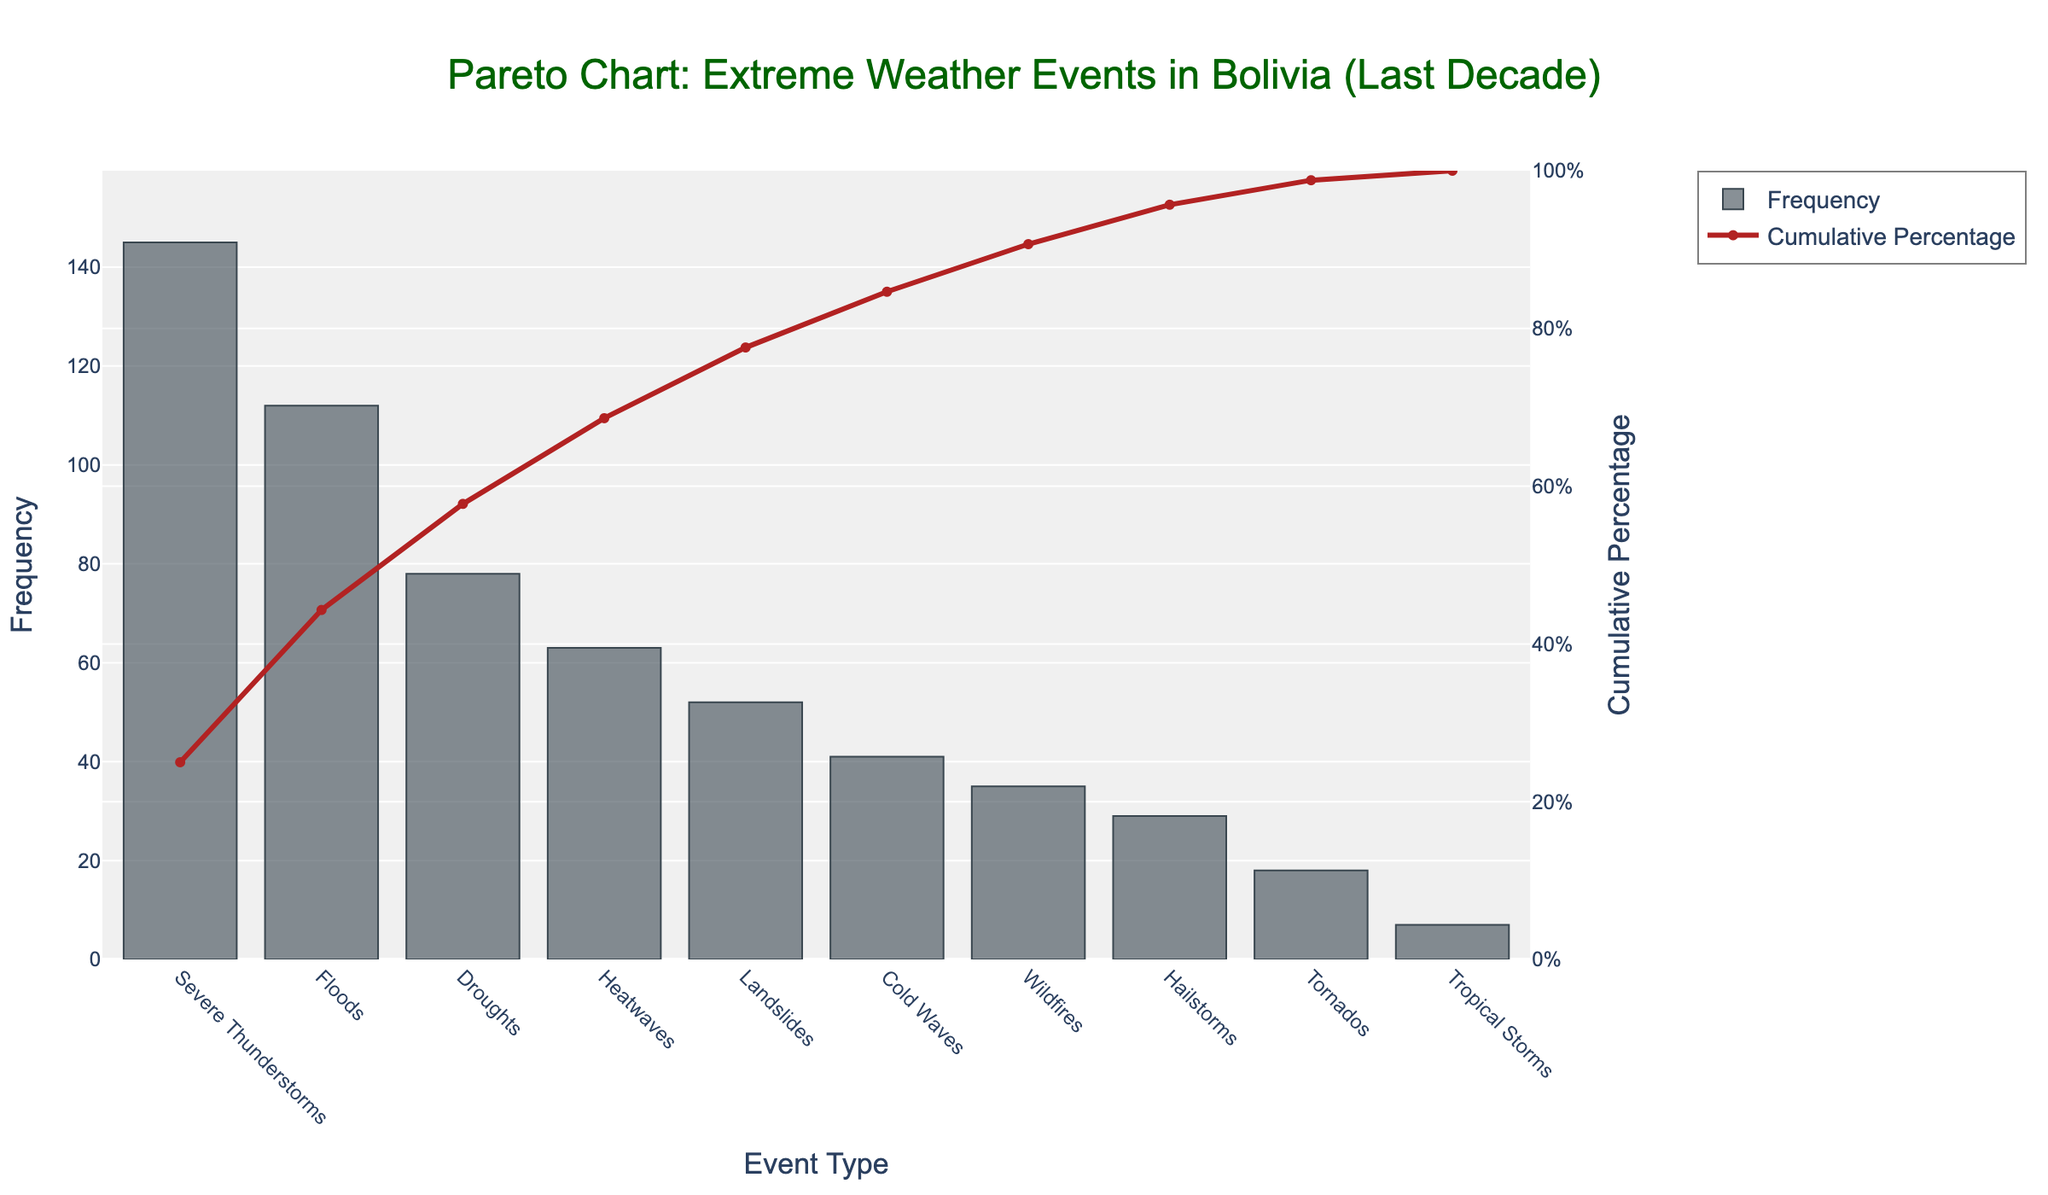How many event types are recorded in the chart? The chart displays 10 types of extreme weather events. You can tell this by counting the unique labels on the x-axis.
Answer: 10 Which extreme weather event has the highest frequency? The event type with the highest bar in the chart represents the one with the highest frequency. In this case, it is "Severe Thunderstorms".
Answer: Severe Thunderstorms What is the cumulative percentage for 'Droughts'? Find the 'Droughts' event type on the x-axis and trace it upwards to the point where its cumulative percentage line intersects the secondary y-axis. The cumulative percentage reads approximately 70%.
Answer: Around 70% What's the sum frequency of heatwaves and landslides combined? Add the frequencies of heatwaves (63) and landslides (52). 63 + 52 = 115
Answer: 115 Which event type contributes to reaching over 80% cumulative percentage for the first time? Follow the cumulative percentage line until it crosses the 80% mark on the secondary y-axis. The corresponding event type on the x-axis at this intersection point is the one that pushes the cumulative percentage over 80%.
Answer: Cold Waves How much more frequent are floods compared to wildfires in the chart? Subtract the frequency of wildfires (35) from the frequency of floods (112). 112 - 35 = 77
Answer: 77 What is the cumulative frequency after the top three events? Sum the frequencies of the top three events: Severe Thunderstorms (145), Floods (112), and Droughts (78). 145 + 112 + 78 = 335
Answer: 335 What percentage does 'Tornados' contribute to the total frequency? Calculate the ratio of the frequency of 'Tornados' (18) to the total frequency and multiply by 100. Total frequency is the sum of all frequencies, which is 580. (18 / 580) * 100 ≈ 3.1%
Answer: 3.1% Which event type has the smallest frequency and how can you tell? The event with the shortest bar in the chart has the smallest frequency, which is 'Tropical Storms'.
Answer: Tropical Storms If you combine the frequencies of the bottom five events, do they surpass the frequency of Severe Thunderstorms? Sum the frequencies of the bottom five events: Wildfires (35), Hailstorms (29), Tornados (18), Tropical Storms (7), and Cold Waves (41). 35 + 29 + 18 + 7 + 41 = 130. Compare this sum to the frequency of Severe Thunderstorms (145). 130 < 145
Answer: No 